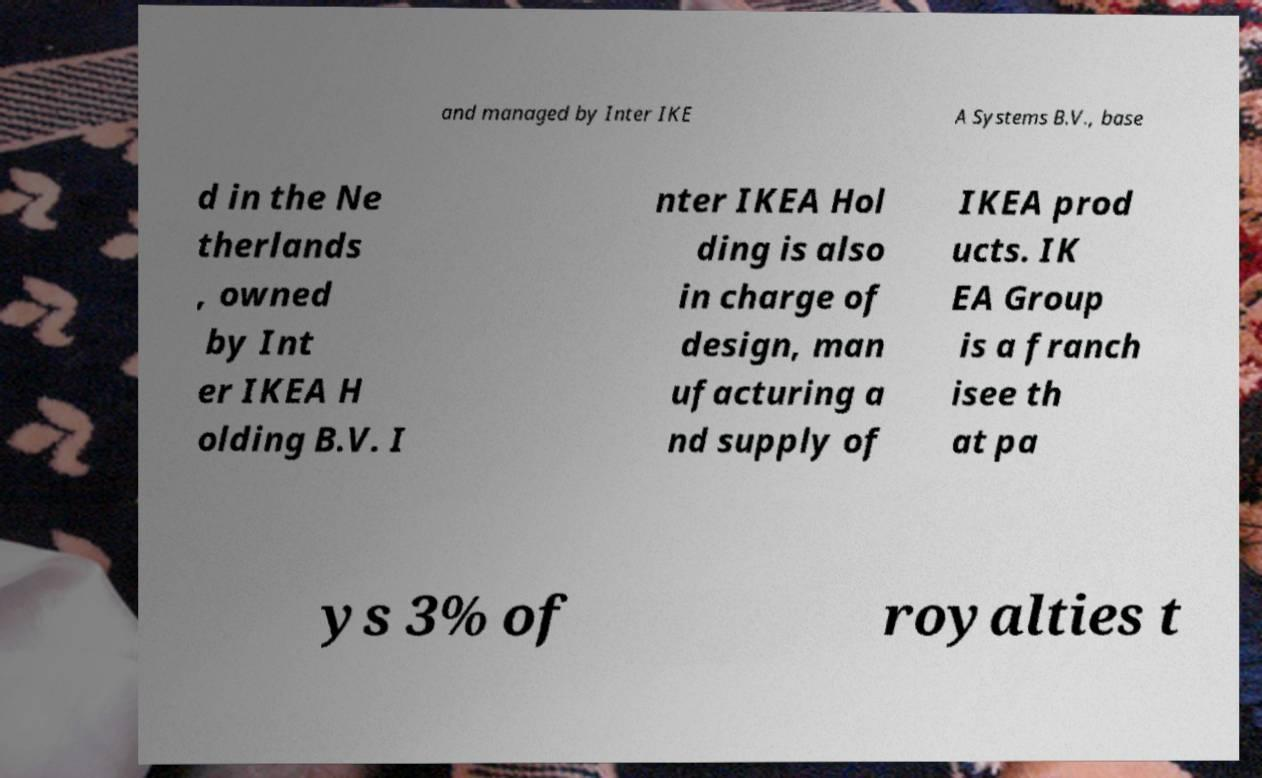Can you accurately transcribe the text from the provided image for me? and managed by Inter IKE A Systems B.V., base d in the Ne therlands , owned by Int er IKEA H olding B.V. I nter IKEA Hol ding is also in charge of design, man ufacturing a nd supply of IKEA prod ucts. IK EA Group is a franch isee th at pa ys 3% of royalties t 